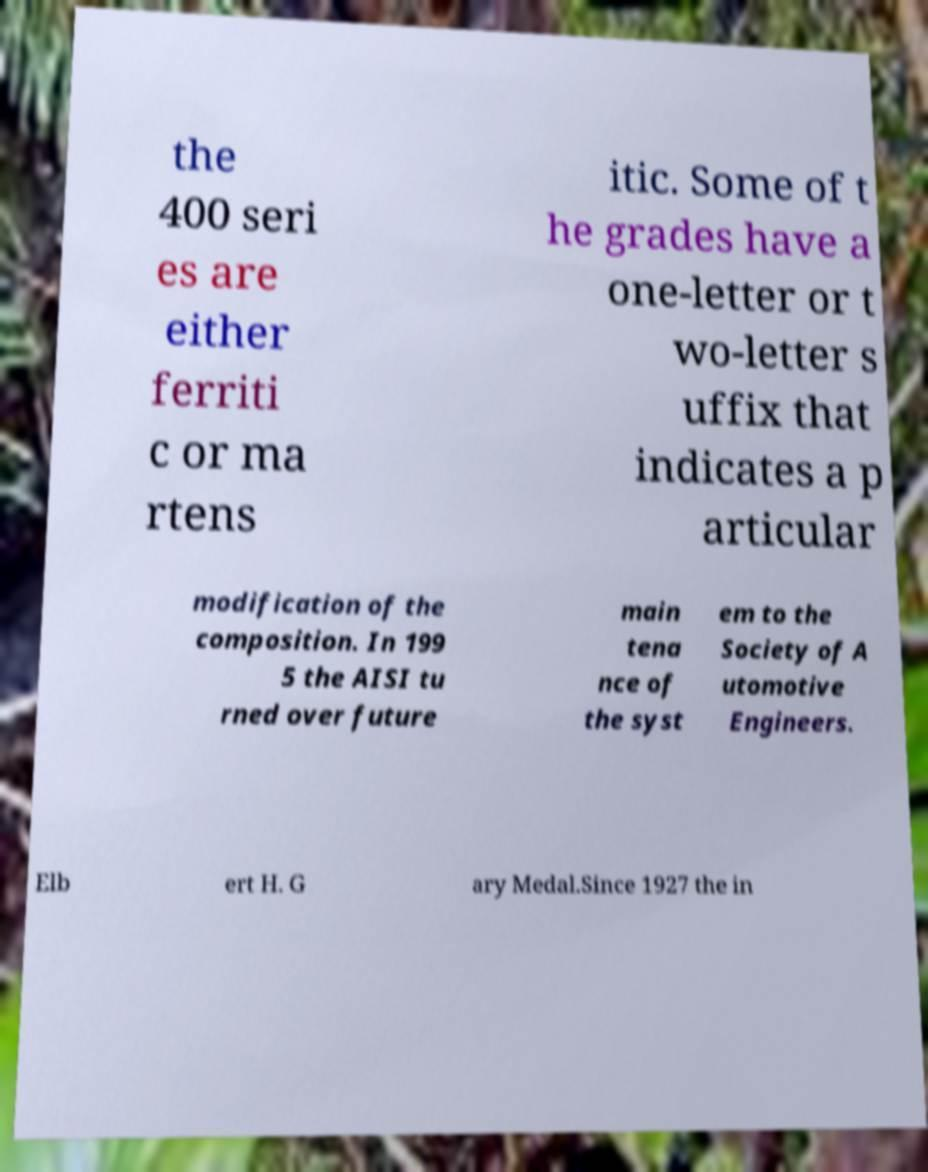There's text embedded in this image that I need extracted. Can you transcribe it verbatim? the 400 seri es are either ferriti c or ma rtens itic. Some of t he grades have a one-letter or t wo-letter s uffix that indicates a p articular modification of the composition. In 199 5 the AISI tu rned over future main tena nce of the syst em to the Society of A utomotive Engineers. Elb ert H. G ary Medal.Since 1927 the in 